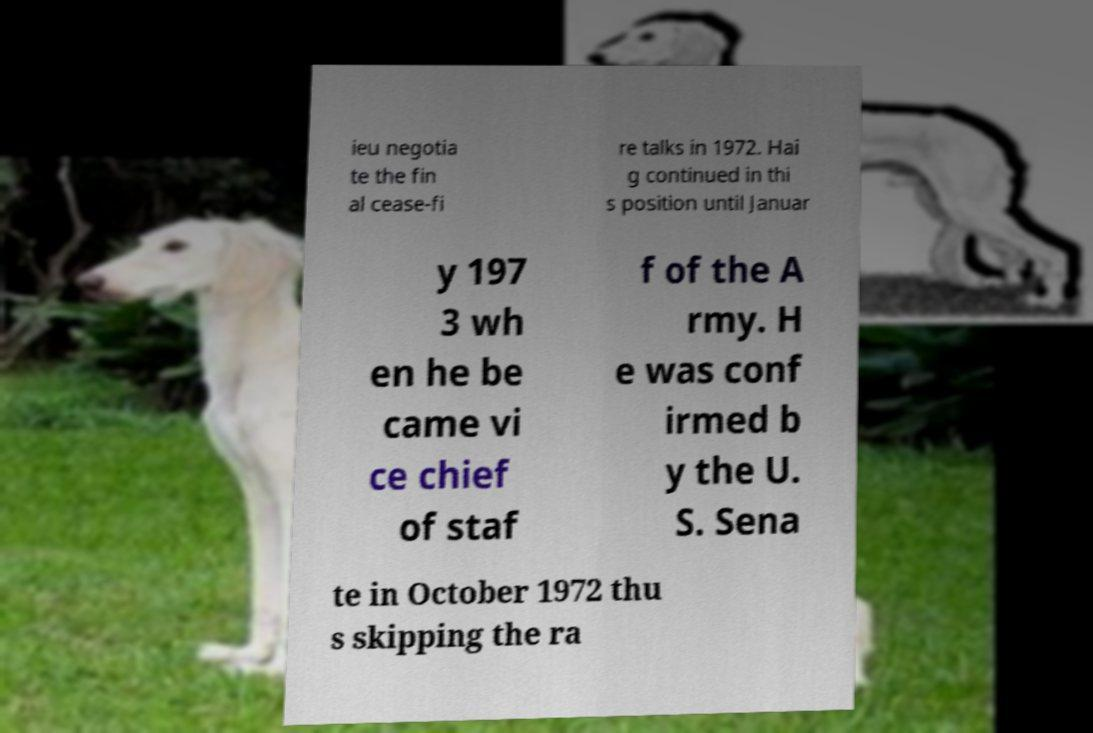What messages or text are displayed in this image? I need them in a readable, typed format. ieu negotia te the fin al cease-fi re talks in 1972. Hai g continued in thi s position until Januar y 197 3 wh en he be came vi ce chief of staf f of the A rmy. H e was conf irmed b y the U. S. Sena te in October 1972 thu s skipping the ra 